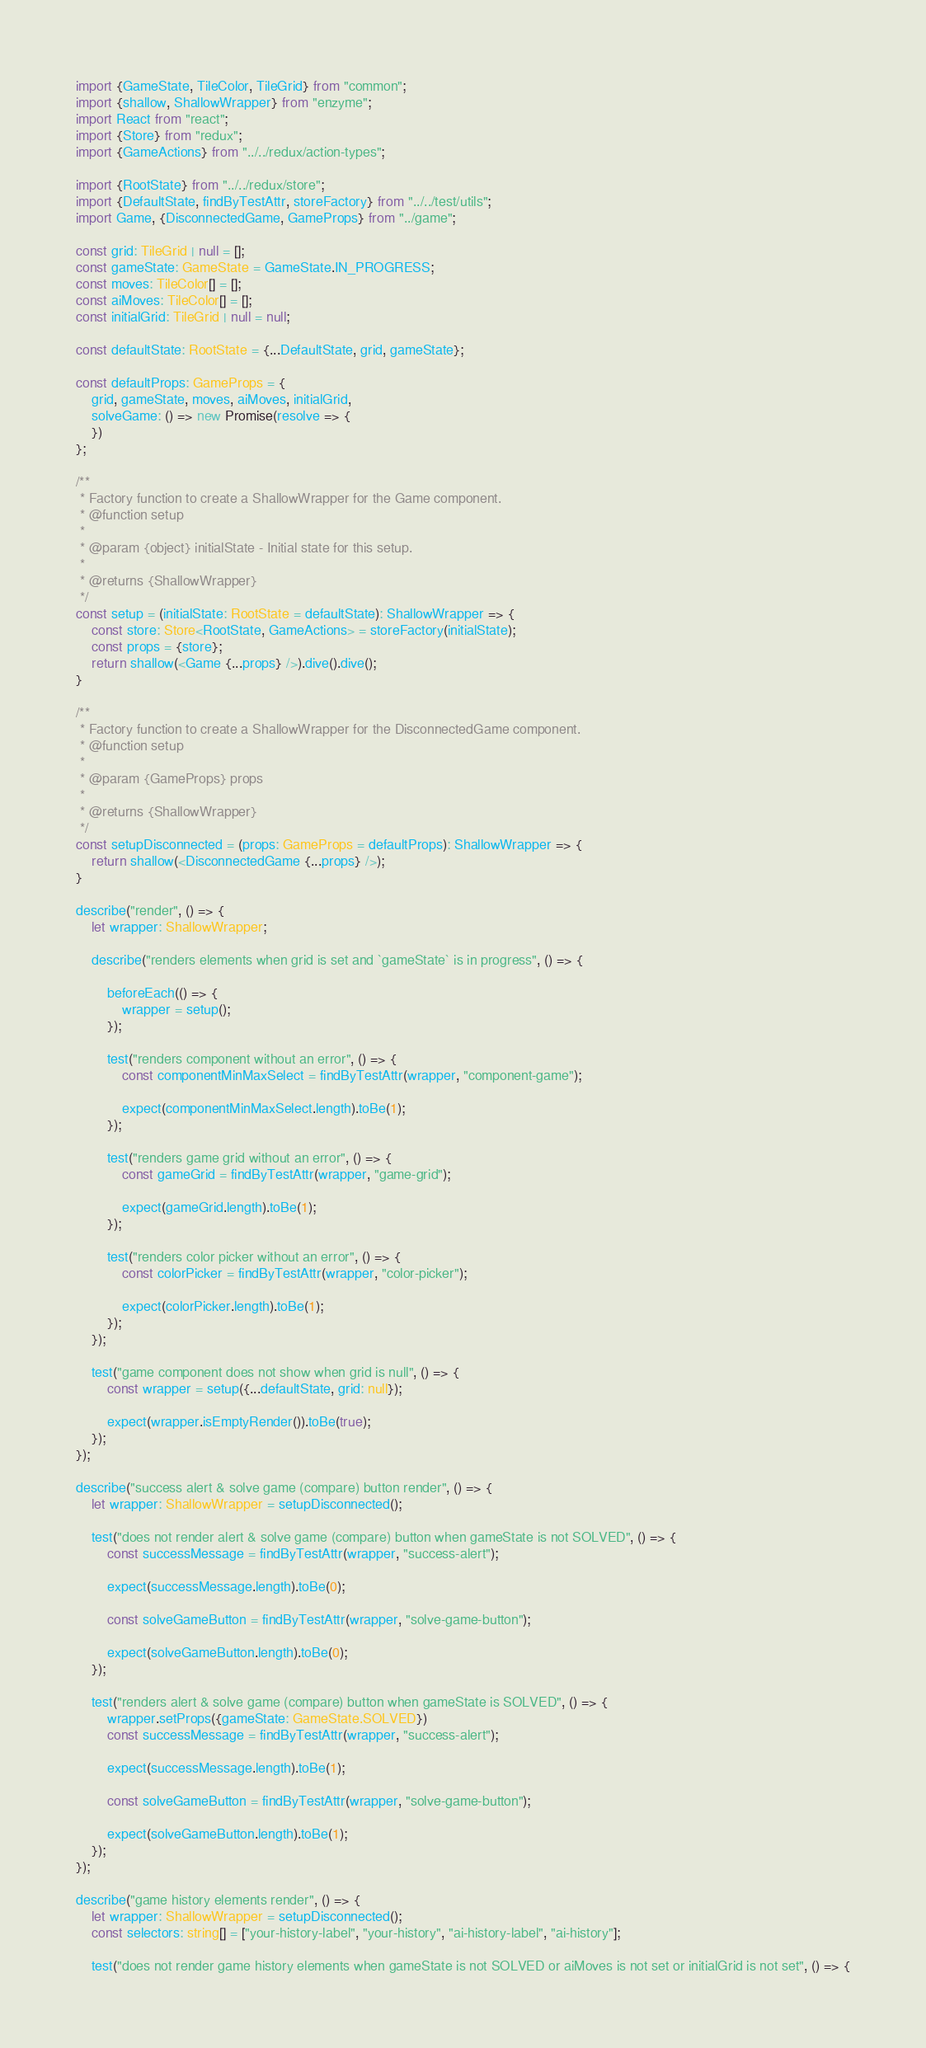<code> <loc_0><loc_0><loc_500><loc_500><_TypeScript_>import {GameState, TileColor, TileGrid} from "common";
import {shallow, ShallowWrapper} from "enzyme";
import React from "react";
import {Store} from "redux";
import {GameActions} from "../../redux/action-types";

import {RootState} from "../../redux/store";
import {DefaultState, findByTestAttr, storeFactory} from "../../test/utils";
import Game, {DisconnectedGame, GameProps} from "../game";

const grid: TileGrid | null = [];
const gameState: GameState = GameState.IN_PROGRESS;
const moves: TileColor[] = [];
const aiMoves: TileColor[] = [];
const initialGrid: TileGrid | null = null;

const defaultState: RootState = {...DefaultState, grid, gameState};

const defaultProps: GameProps = {
    grid, gameState, moves, aiMoves, initialGrid,
    solveGame: () => new Promise(resolve => {
    })
};

/**
 * Factory function to create a ShallowWrapper for the Game component.
 * @function setup
 *
 * @param {object} initialState - Initial state for this setup.
 *
 * @returns {ShallowWrapper}
 */
const setup = (initialState: RootState = defaultState): ShallowWrapper => {
    const store: Store<RootState, GameActions> = storeFactory(initialState);
    const props = {store};
    return shallow(<Game {...props} />).dive().dive();
}

/**
 * Factory function to create a ShallowWrapper for the DisconnectedGame component.
 * @function setup
 *
 * @param {GameProps} props
 *
 * @returns {ShallowWrapper}
 */
const setupDisconnected = (props: GameProps = defaultProps): ShallowWrapper => {
    return shallow(<DisconnectedGame {...props} />);
}

describe("render", () => {
    let wrapper: ShallowWrapper;

    describe("renders elements when grid is set and `gameState` is in progress", () => {

        beforeEach(() => {
            wrapper = setup();
        });

        test("renders component without an error", () => {
            const componentMinMaxSelect = findByTestAttr(wrapper, "component-game");

            expect(componentMinMaxSelect.length).toBe(1);
        });

        test("renders game grid without an error", () => {
            const gameGrid = findByTestAttr(wrapper, "game-grid");

            expect(gameGrid.length).toBe(1);
        });

        test("renders color picker without an error", () => {
            const colorPicker = findByTestAttr(wrapper, "color-picker");

            expect(colorPicker.length).toBe(1);
        });
    });

    test("game component does not show when grid is null", () => {
        const wrapper = setup({...defaultState, grid: null});

        expect(wrapper.isEmptyRender()).toBe(true);
    });
});

describe("success alert & solve game (compare) button render", () => {
    let wrapper: ShallowWrapper = setupDisconnected();

    test("does not render alert & solve game (compare) button when gameState is not SOLVED", () => {
        const successMessage = findByTestAttr(wrapper, "success-alert");

        expect(successMessage.length).toBe(0);

        const solveGameButton = findByTestAttr(wrapper, "solve-game-button");

        expect(solveGameButton.length).toBe(0);
    });

    test("renders alert & solve game (compare) button when gameState is SOLVED", () => {
        wrapper.setProps({gameState: GameState.SOLVED})
        const successMessage = findByTestAttr(wrapper, "success-alert");

        expect(successMessage.length).toBe(1);

        const solveGameButton = findByTestAttr(wrapper, "solve-game-button");

        expect(solveGameButton.length).toBe(1);
    });
});

describe("game history elements render", () => {
    let wrapper: ShallowWrapper = setupDisconnected();
    const selectors: string[] = ["your-history-label", "your-history", "ai-history-label", "ai-history"];

    test("does not render game history elements when gameState is not SOLVED or aiMoves is not set or initialGrid is not set", () => {</code> 